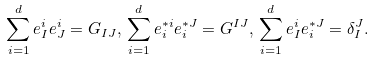<formula> <loc_0><loc_0><loc_500><loc_500>\sum _ { i = 1 } ^ { d } e _ { I } ^ { i } e _ { J } ^ { i } = G _ { I J } , \, \sum _ { i = 1 } ^ { d } e _ { i } ^ { * i } e _ { i } ^ { * J } = G ^ { I J } , \, \sum _ { i = 1 } ^ { d } e _ { I } ^ { i } e _ { i } ^ { * J } = \delta _ { I } ^ { J } .</formula> 